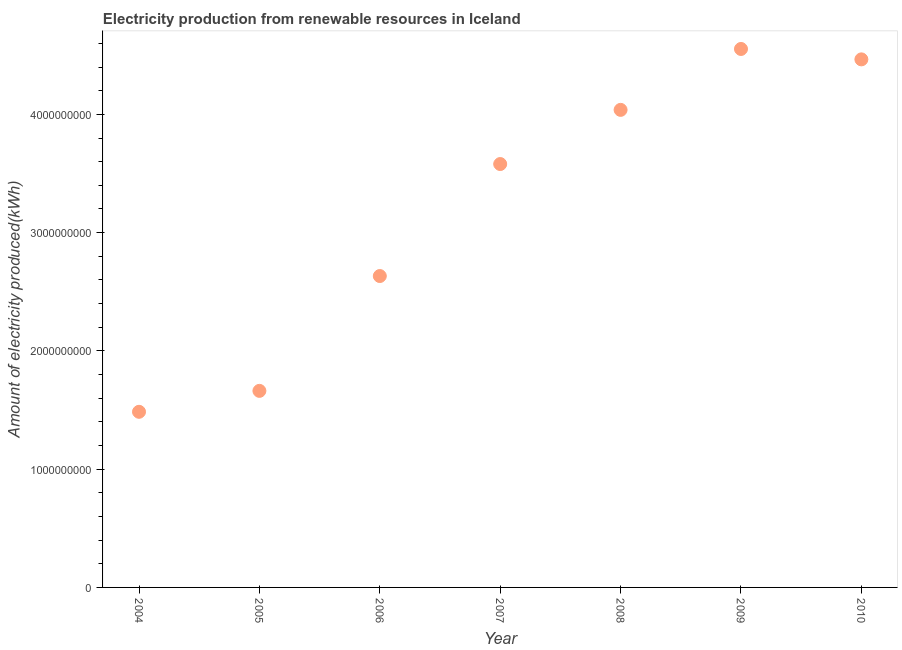What is the amount of electricity produced in 2010?
Provide a succinct answer. 4.46e+09. Across all years, what is the maximum amount of electricity produced?
Provide a short and direct response. 4.55e+09. Across all years, what is the minimum amount of electricity produced?
Your answer should be compact. 1.48e+09. What is the sum of the amount of electricity produced?
Keep it short and to the point. 2.24e+1. What is the difference between the amount of electricity produced in 2006 and 2009?
Give a very brief answer. -1.92e+09. What is the average amount of electricity produced per year?
Your answer should be compact. 3.20e+09. What is the median amount of electricity produced?
Your response must be concise. 3.58e+09. Do a majority of the years between 2005 and 2008 (inclusive) have amount of electricity produced greater than 1200000000 kWh?
Ensure brevity in your answer.  Yes. What is the ratio of the amount of electricity produced in 2006 to that in 2007?
Keep it short and to the point. 0.74. Is the amount of electricity produced in 2005 less than that in 2006?
Provide a short and direct response. Yes. Is the difference between the amount of electricity produced in 2007 and 2009 greater than the difference between any two years?
Offer a terse response. No. What is the difference between the highest and the second highest amount of electricity produced?
Your response must be concise. 8.80e+07. Is the sum of the amount of electricity produced in 2006 and 2010 greater than the maximum amount of electricity produced across all years?
Provide a short and direct response. Yes. What is the difference between the highest and the lowest amount of electricity produced?
Give a very brief answer. 3.07e+09. Does the amount of electricity produced monotonically increase over the years?
Your answer should be compact. No. How many dotlines are there?
Offer a terse response. 1. What is the difference between two consecutive major ticks on the Y-axis?
Offer a terse response. 1.00e+09. Does the graph contain grids?
Make the answer very short. No. What is the title of the graph?
Your answer should be compact. Electricity production from renewable resources in Iceland. What is the label or title of the X-axis?
Provide a short and direct response. Year. What is the label or title of the Y-axis?
Provide a succinct answer. Amount of electricity produced(kWh). What is the Amount of electricity produced(kWh) in 2004?
Keep it short and to the point. 1.48e+09. What is the Amount of electricity produced(kWh) in 2005?
Give a very brief answer. 1.66e+09. What is the Amount of electricity produced(kWh) in 2006?
Make the answer very short. 2.63e+09. What is the Amount of electricity produced(kWh) in 2007?
Provide a succinct answer. 3.58e+09. What is the Amount of electricity produced(kWh) in 2008?
Keep it short and to the point. 4.04e+09. What is the Amount of electricity produced(kWh) in 2009?
Your answer should be compact. 4.55e+09. What is the Amount of electricity produced(kWh) in 2010?
Keep it short and to the point. 4.46e+09. What is the difference between the Amount of electricity produced(kWh) in 2004 and 2005?
Provide a succinct answer. -1.77e+08. What is the difference between the Amount of electricity produced(kWh) in 2004 and 2006?
Ensure brevity in your answer.  -1.15e+09. What is the difference between the Amount of electricity produced(kWh) in 2004 and 2007?
Keep it short and to the point. -2.10e+09. What is the difference between the Amount of electricity produced(kWh) in 2004 and 2008?
Provide a succinct answer. -2.55e+09. What is the difference between the Amount of electricity produced(kWh) in 2004 and 2009?
Make the answer very short. -3.07e+09. What is the difference between the Amount of electricity produced(kWh) in 2004 and 2010?
Ensure brevity in your answer.  -2.98e+09. What is the difference between the Amount of electricity produced(kWh) in 2005 and 2006?
Your answer should be very brief. -9.71e+08. What is the difference between the Amount of electricity produced(kWh) in 2005 and 2007?
Ensure brevity in your answer.  -1.92e+09. What is the difference between the Amount of electricity produced(kWh) in 2005 and 2008?
Your response must be concise. -2.38e+09. What is the difference between the Amount of electricity produced(kWh) in 2005 and 2009?
Your answer should be compact. -2.89e+09. What is the difference between the Amount of electricity produced(kWh) in 2005 and 2010?
Provide a short and direct response. -2.80e+09. What is the difference between the Amount of electricity produced(kWh) in 2006 and 2007?
Keep it short and to the point. -9.47e+08. What is the difference between the Amount of electricity produced(kWh) in 2006 and 2008?
Your answer should be very brief. -1.40e+09. What is the difference between the Amount of electricity produced(kWh) in 2006 and 2009?
Your answer should be compact. -1.92e+09. What is the difference between the Amount of electricity produced(kWh) in 2006 and 2010?
Your answer should be compact. -1.83e+09. What is the difference between the Amount of electricity produced(kWh) in 2007 and 2008?
Offer a terse response. -4.58e+08. What is the difference between the Amount of electricity produced(kWh) in 2007 and 2009?
Your answer should be very brief. -9.73e+08. What is the difference between the Amount of electricity produced(kWh) in 2007 and 2010?
Give a very brief answer. -8.85e+08. What is the difference between the Amount of electricity produced(kWh) in 2008 and 2009?
Offer a terse response. -5.15e+08. What is the difference between the Amount of electricity produced(kWh) in 2008 and 2010?
Your answer should be compact. -4.27e+08. What is the difference between the Amount of electricity produced(kWh) in 2009 and 2010?
Make the answer very short. 8.80e+07. What is the ratio of the Amount of electricity produced(kWh) in 2004 to that in 2005?
Your answer should be compact. 0.89. What is the ratio of the Amount of electricity produced(kWh) in 2004 to that in 2006?
Provide a short and direct response. 0.56. What is the ratio of the Amount of electricity produced(kWh) in 2004 to that in 2007?
Ensure brevity in your answer.  0.41. What is the ratio of the Amount of electricity produced(kWh) in 2004 to that in 2008?
Your response must be concise. 0.37. What is the ratio of the Amount of electricity produced(kWh) in 2004 to that in 2009?
Give a very brief answer. 0.33. What is the ratio of the Amount of electricity produced(kWh) in 2004 to that in 2010?
Offer a very short reply. 0.33. What is the ratio of the Amount of electricity produced(kWh) in 2005 to that in 2006?
Provide a short and direct response. 0.63. What is the ratio of the Amount of electricity produced(kWh) in 2005 to that in 2007?
Provide a short and direct response. 0.46. What is the ratio of the Amount of electricity produced(kWh) in 2005 to that in 2008?
Your answer should be compact. 0.41. What is the ratio of the Amount of electricity produced(kWh) in 2005 to that in 2009?
Offer a terse response. 0.36. What is the ratio of the Amount of electricity produced(kWh) in 2005 to that in 2010?
Give a very brief answer. 0.37. What is the ratio of the Amount of electricity produced(kWh) in 2006 to that in 2007?
Ensure brevity in your answer.  0.73. What is the ratio of the Amount of electricity produced(kWh) in 2006 to that in 2008?
Provide a short and direct response. 0.65. What is the ratio of the Amount of electricity produced(kWh) in 2006 to that in 2009?
Your answer should be compact. 0.58. What is the ratio of the Amount of electricity produced(kWh) in 2006 to that in 2010?
Offer a very short reply. 0.59. What is the ratio of the Amount of electricity produced(kWh) in 2007 to that in 2008?
Offer a terse response. 0.89. What is the ratio of the Amount of electricity produced(kWh) in 2007 to that in 2009?
Your answer should be very brief. 0.79. What is the ratio of the Amount of electricity produced(kWh) in 2007 to that in 2010?
Your answer should be very brief. 0.8. What is the ratio of the Amount of electricity produced(kWh) in 2008 to that in 2009?
Ensure brevity in your answer.  0.89. What is the ratio of the Amount of electricity produced(kWh) in 2008 to that in 2010?
Provide a succinct answer. 0.9. 